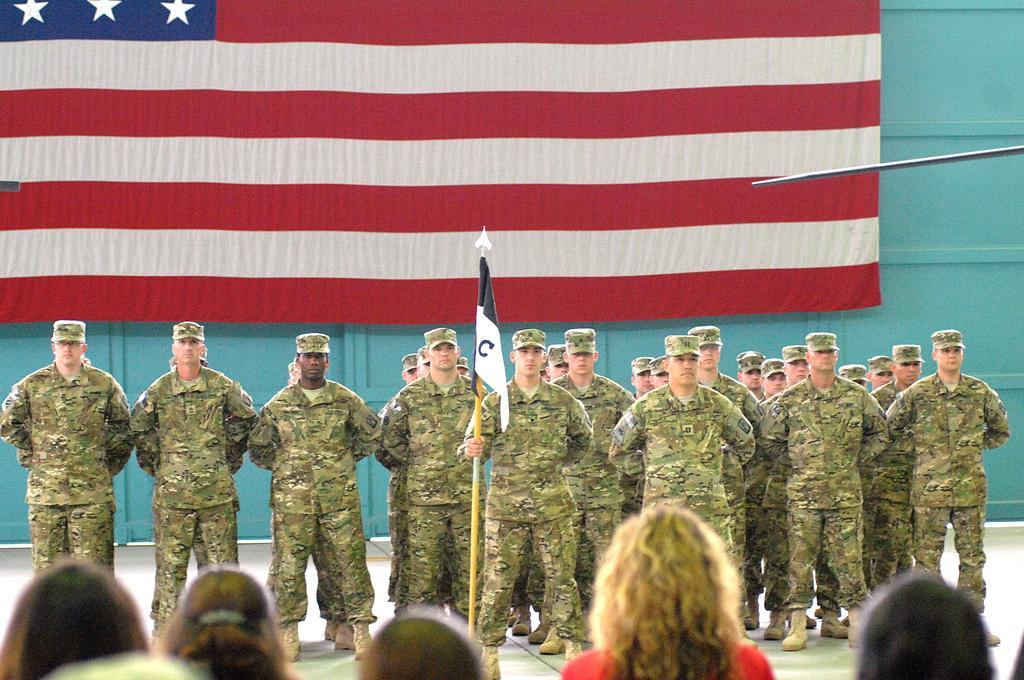Can you describe this image briefly? In the foreground of this image, at the bottom, there are heads of a person. In the middle, there are few men standing and a man is holding a flag. In the background, there is a flag on the wall. 